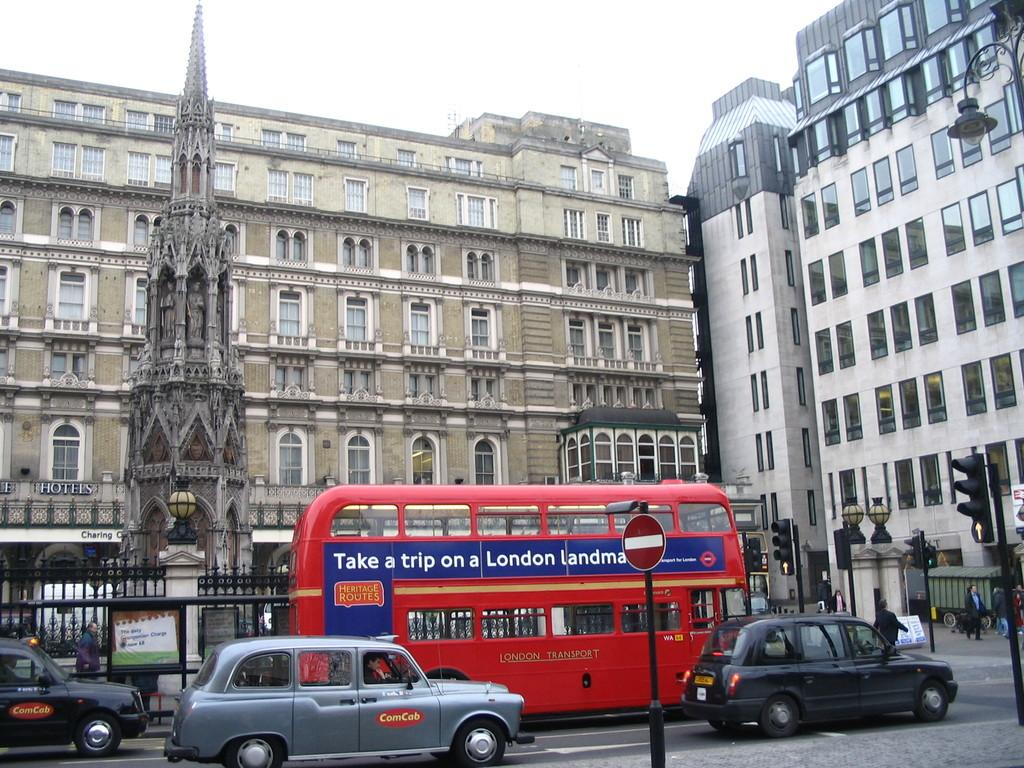<image>
Create a compact narrative representing the image presented. A double decker red Heritage Routes bus drives through traffic. 